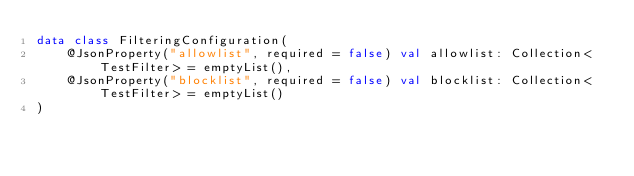<code> <loc_0><loc_0><loc_500><loc_500><_Kotlin_>data class FilteringConfiguration(
    @JsonProperty("allowlist", required = false) val allowlist: Collection<TestFilter> = emptyList(),
    @JsonProperty("blocklist", required = false) val blocklist: Collection<TestFilter> = emptyList()
)
</code> 